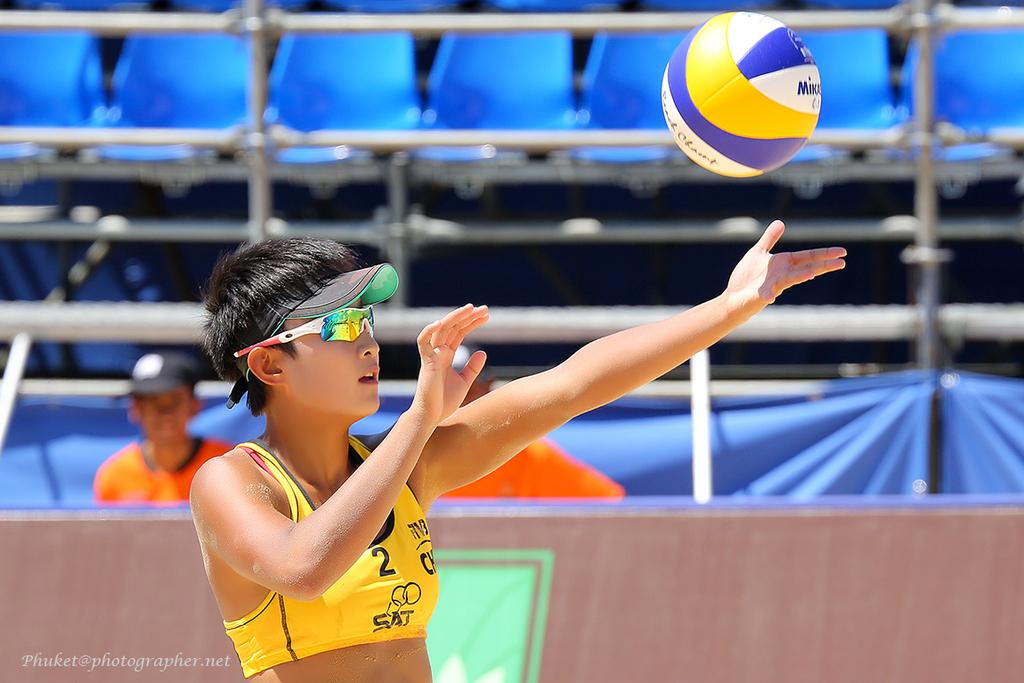<image>
Write a terse but informative summary of the picture. a person playing a sport with the number 2 on her shirt 